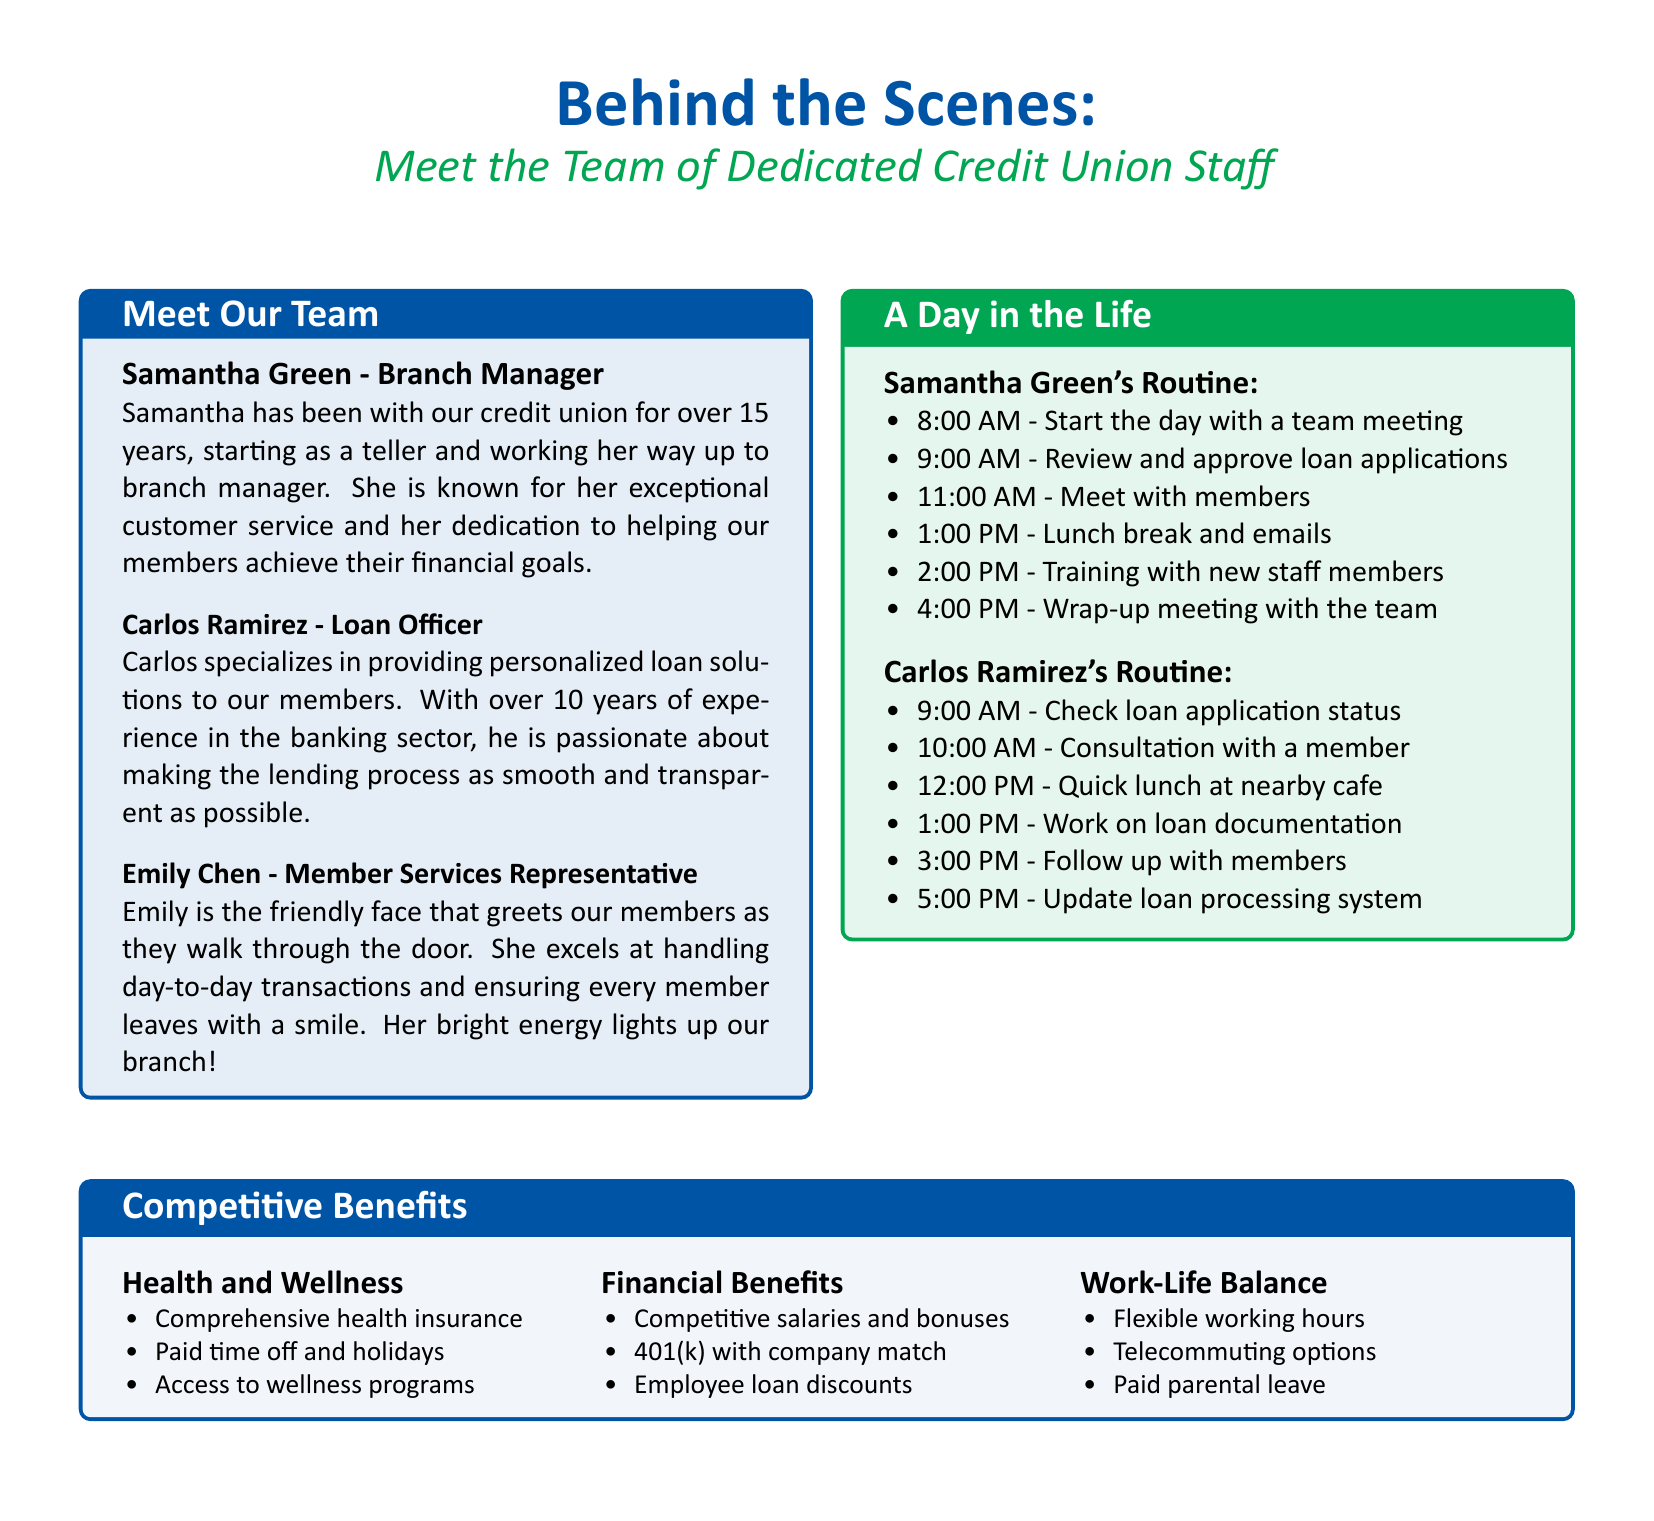What is Samantha Green's role? Samantha Green is identified as the Branch Manager in the staff profiles.
Answer: Branch Manager How many years has Carlos Ramirez been in the banking sector? The document states that Carlos Ramirez has over 10 years of experience in the banking sector.
Answer: Over 10 years At what time does Samantha Green's workday begin? According to the 'Day in the Life' section, Samantha Green's workday starts at 8:00 AM.
Answer: 8:00 AM What type of insurance is provided in the Health and Wellness benefits? The document mentions "Comprehensive health insurance" as a part of the Health and Wellness benefits.
Answer: Comprehensive health insurance What is one of the financial benefits offered to employees? The document lists "Competitive salaries and bonuses" as part of the financial benefits provided to employees.
Answer: Competitive salaries and bonuses Which staff member handles loan documentation? Carlos Ramirez is responsible for working on loan documentation as noted in his daily routine.
Answer: Carlos Ramirez How often does Samantha meet with team members according to her daily routine? The routine outlines a "Wrap-up meeting with the team" at 4:00 PM, indicating daily interaction with team members.
Answer: Daily What aspect of employee benefits promotes flexibility? The benefits section mentions "Flexible working hours" under Work-Life Balance, promoting flexibility for staff.
Answer: Flexible working hours Which staff member is described as "the friendly face"? Emily Chen is referred to as "the friendly face" that greets members when they enter the credit union.
Answer: Emily Chen 